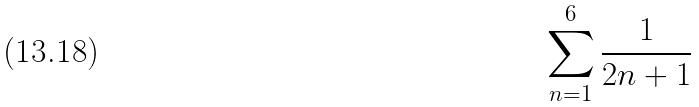Convert formula to latex. <formula><loc_0><loc_0><loc_500><loc_500>\sum _ { n = 1 } ^ { 6 } \frac { 1 } { 2 n + 1 }</formula> 